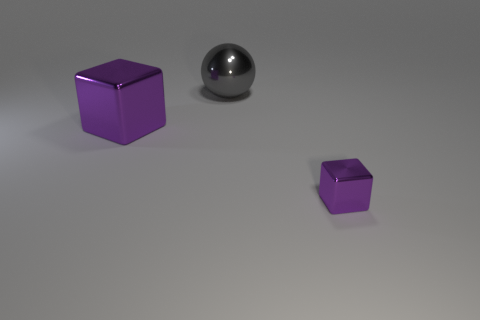There is a purple thing that is to the left of the small purple object; what is its shape?
Keep it short and to the point. Cube. Is there a block that has the same size as the gray ball?
Your answer should be compact. Yes. There is a purple object that is the same size as the gray shiny ball; what material is it?
Your answer should be very brief. Metal. What size is the purple metal thing right of the big purple shiny block?
Your answer should be compact. Small. The shiny ball is what size?
Give a very brief answer. Large. Does the gray sphere have the same size as the purple metallic object on the left side of the large gray ball?
Keep it short and to the point. Yes. There is a block that is behind the purple object that is in front of the large block; what color is it?
Your answer should be compact. Purple. Are there an equal number of metallic spheres that are behind the big gray ball and metallic blocks that are to the right of the large metal block?
Ensure brevity in your answer.  No. Is the material of the tiny purple cube right of the large purple shiny thing the same as the big purple object?
Provide a short and direct response. Yes. What color is the metal thing that is in front of the gray metallic ball and right of the big purple metal cube?
Your answer should be compact. Purple. 